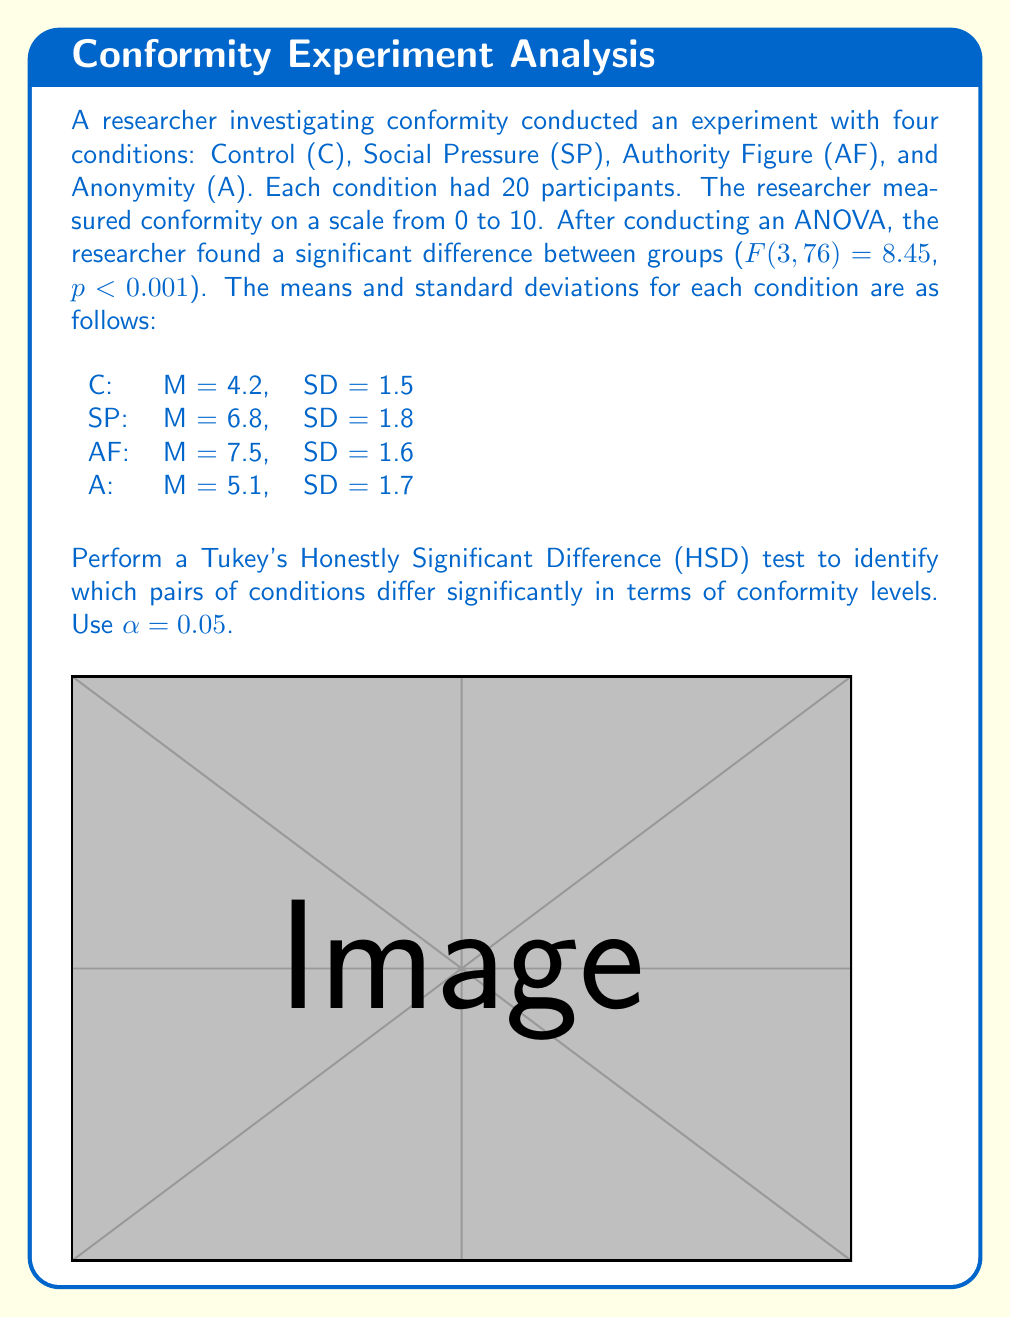Give your solution to this math problem. To perform Tukey's HSD test, we need to follow these steps:

1. Calculate the Mean Square Error (MSE) from the ANOVA:
   $$MSE = \frac{SS_{within}}{df_{within}} = \frac{SS_{total} - SS_{between}}{N - k}$$
   where N = total number of participants (80) and k = number of groups (4).

2. Calculate the q statistic for each pair of means:
   $$q = \frac{|\bar{X_i} - \bar{X_j}|}{\sqrt{\frac{MSE}{n}}}$$
   where n = number of participants per group (20).

3. Compare the calculated q value with the critical q value from the Studentized Range distribution.

Step 1: Calculate MSE
We don't have the SS values, but we can use the F-statistic to derive MSE:
$$F = \frac{MS_{between}}{MS_{within}} = \frac{MS_{between}}{MSE} = 8.45$$
$$MSE = \frac{MS_{between}}{8.45}$$

We need to estimate $MS_{between}$. Using the variation in means:
$$MS_{between} \approx \frac{\sum_{i=1}^{k} n_i(\bar{X_i} - \bar{X})^2}{k-1}$$
$$\bar{X} = \frac{4.2 + 6.8 + 7.5 + 5.1}{4} = 5.9$$
$$MS_{between} \approx \frac{20[(4.2-5.9)^2 + (6.8-5.9)^2 + (7.5-5.9)^2 + (5.1-5.9)^2]}{3} \approx 21.45$$

Now we can estimate MSE:
$$MSE \approx \frac{21.45}{8.45} \approx 2.54$$

Step 2: Calculate q statistics
$$q = \frac{|\bar{X_i} - \bar{X_j}|}{\sqrt{\frac{2.54}{20}}} = \frac{|\bar{X_i} - \bar{X_j}|}{0.356}$$

For each pair:
C vs SP: q = (6.8 - 4.2) / 0.356 = 7.30
C vs AF: q = (7.5 - 4.2) / 0.356 = 9.27
C vs A: q = (5.1 - 4.2) / 0.356 = 2.53
SP vs AF: q = (7.5 - 6.8) / 0.356 = 1.97
SP vs A: q = (6.8 - 5.1) / 0.356 = 4.78
AF vs A: q = (7.5 - 5.1) / 0.356 = 6.74

Step 3: Compare with critical q
For α = 0.05, k = 4, df = 76, the critical q ≈ 3.71

Significant differences (q > 3.71):
- Control vs Social Pressure
- Control vs Authority Figure
- Social Pressure vs Anonymity
- Authority Figure vs Anonymity
Answer: Significant differences: C-SP, C-AF, SP-A, AF-A 